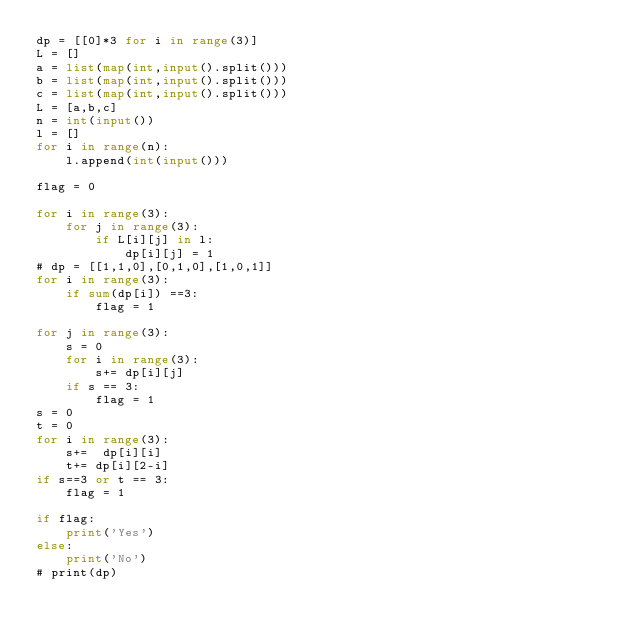<code> <loc_0><loc_0><loc_500><loc_500><_Python_>dp = [[0]*3 for i in range(3)]
L = []
a = list(map(int,input().split()))
b = list(map(int,input().split()))
c = list(map(int,input().split()))
L = [a,b,c]
n = int(input())
l = []
for i in range(n):
    l.append(int(input()))

flag = 0 

for i in range(3):
    for j in range(3):
        if L[i][j] in l:
            dp[i][j] = 1
# dp = [[1,1,0],[0,1,0],[1,0,1]]
for i in range(3):
    if sum(dp[i]) ==3:
        flag = 1

for j in range(3):
    s = 0
    for i in range(3):
        s+= dp[i][j]
    if s == 3:
        flag = 1
s = 0
t = 0
for i in range(3):
    s+=  dp[i][i]
    t+= dp[i][2-i]
if s==3 or t == 3:
    flag = 1
    
if flag:
    print('Yes')
else:
    print('No')
# print(dp)</code> 